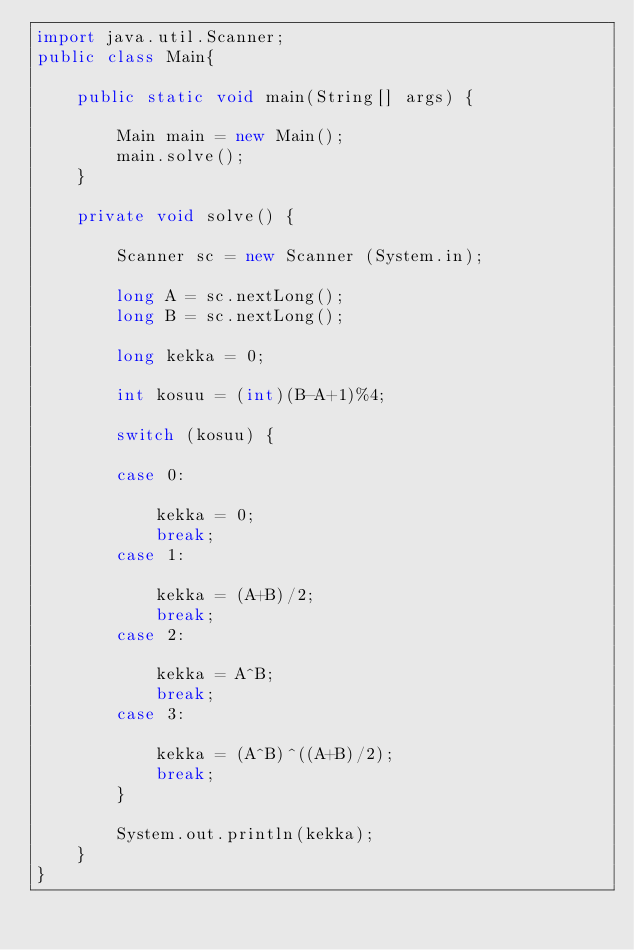<code> <loc_0><loc_0><loc_500><loc_500><_Java_>import java.util.Scanner;
public class Main{

	public static void main(String[] args) {

		Main main = new Main();
		main.solve();
	}

	private void solve() {

		Scanner sc = new Scanner (System.in);

		long A = sc.nextLong();
		long B = sc.nextLong();

		long kekka = 0;

		int kosuu = (int)(B-A+1)%4;

		switch (kosuu) {

		case 0:

			kekka = 0;
			break;
		case 1:

			kekka = (A+B)/2;
			break;
		case 2:

			kekka = A^B;
			break;
		case 3:

			kekka = (A^B)^((A+B)/2);
			break;
		}

		System.out.println(kekka);
	}
}</code> 